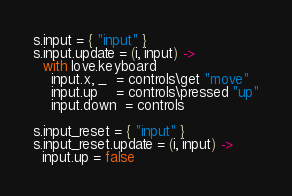<code> <loc_0><loc_0><loc_500><loc_500><_MoonScript_>s.input = { "input" }
s.input.update = (i, input) ->
  with love.keyboard
    input.x, _  = controls\get "move"
    input.up    = controls\pressed "up"
    input.down  = controls

s.input_reset = { "input" }
s.input_reset.update = (i, input) ->
  input.up = false
</code> 